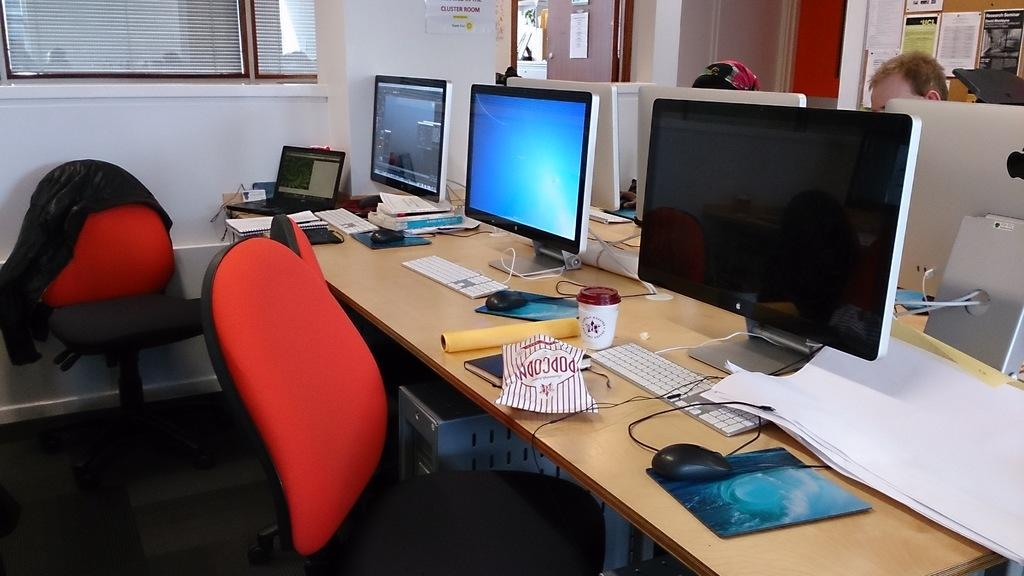<image>
Write a terse but informative summary of the picture. a desk with three monitors has a bag of popcorn sitting on it. 